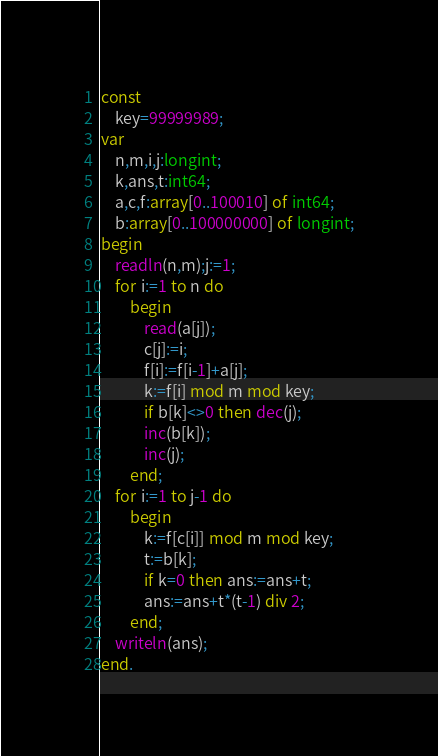Convert code to text. <code><loc_0><loc_0><loc_500><loc_500><_Pascal_>const
    key=99999989;
var
    n,m,i,j:longint;
    k,ans,t:int64;
    a,c,f:array[0..100010] of int64;
    b:array[0..100000000] of longint;
begin
    readln(n,m);j:=1;
    for i:=1 to n do
        begin
            read(a[j]);
            c[j]:=i;
            f[i]:=f[i-1]+a[j];
            k:=f[i] mod m mod key;
            if b[k]<>0 then dec(j);
            inc(b[k]);
            inc(j);
        end;
    for i:=1 to j-1 do
        begin 
            k:=f[c[i]] mod m mod key;
            t:=b[k];
            if k=0 then ans:=ans+t;
            ans:=ans+t*(t-1) div 2;
        end;
    writeln(ans);
end.</code> 